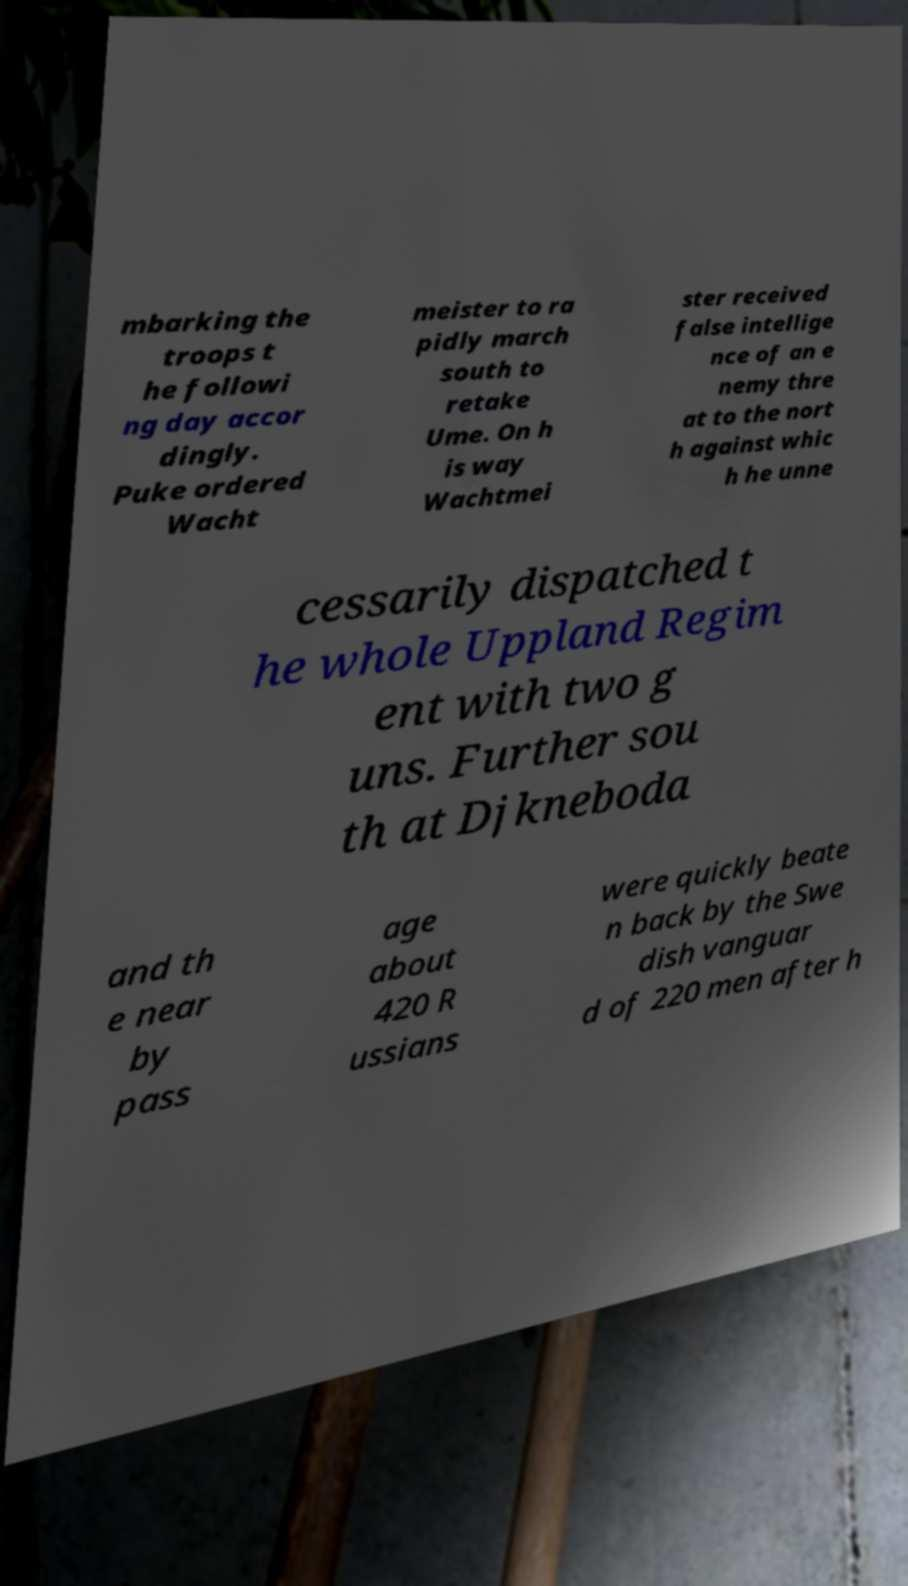Can you accurately transcribe the text from the provided image for me? mbarking the troops t he followi ng day accor dingly. Puke ordered Wacht meister to ra pidly march south to retake Ume. On h is way Wachtmei ster received false intellige nce of an e nemy thre at to the nort h against whic h he unne cessarily dispatched t he whole Uppland Regim ent with two g uns. Further sou th at Djkneboda and th e near by pass age about 420 R ussians were quickly beate n back by the Swe dish vanguar d of 220 men after h 